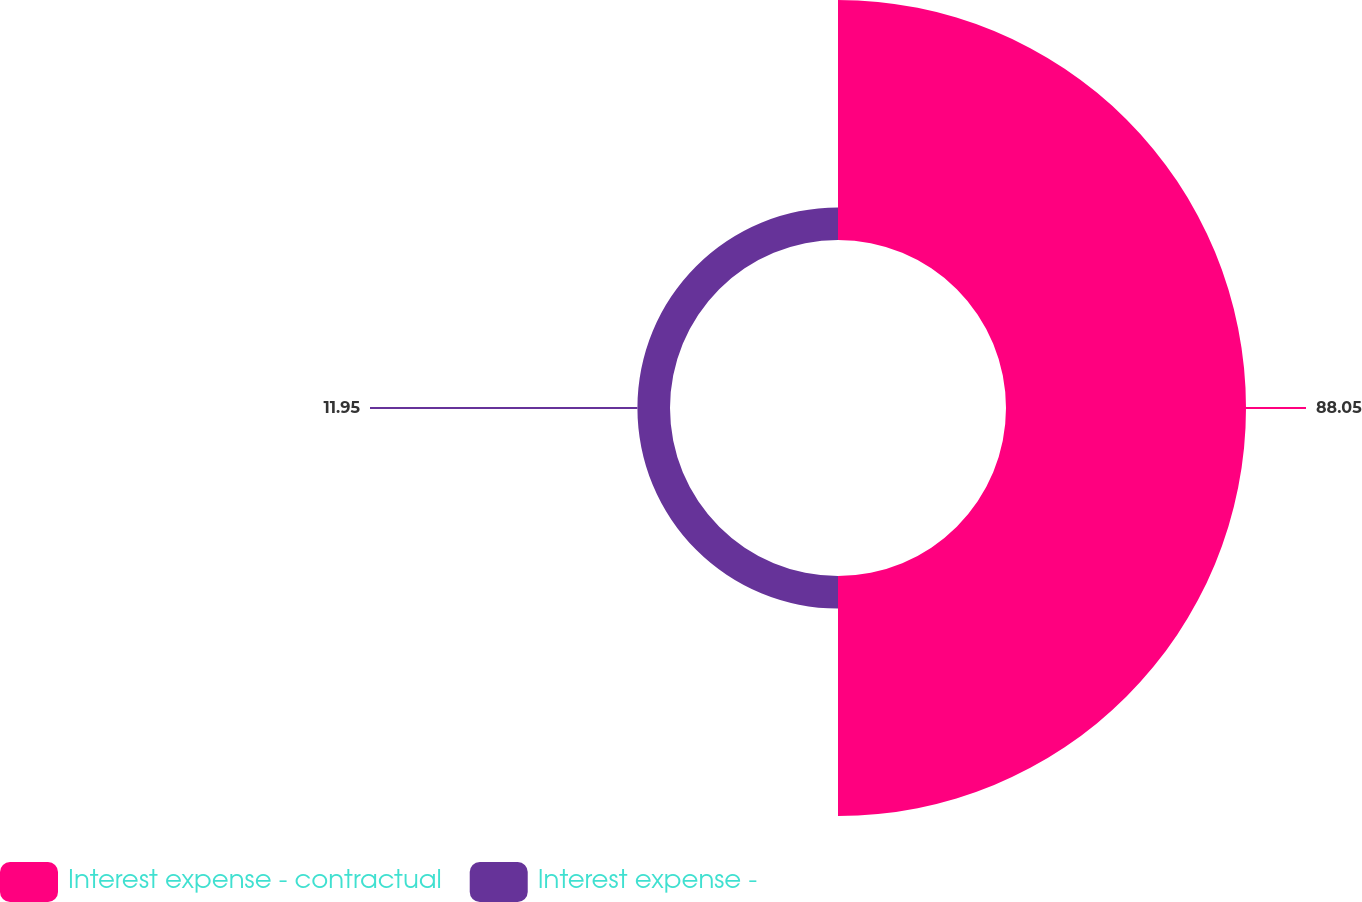Convert chart. <chart><loc_0><loc_0><loc_500><loc_500><pie_chart><fcel>Interest expense - contractual<fcel>Interest expense -<nl><fcel>88.05%<fcel>11.95%<nl></chart> 